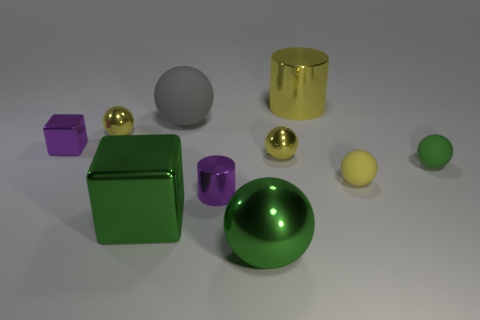Subtract all yellow balls. How many were subtracted if there are1yellow balls left? 2 Subtract all blue blocks. How many yellow spheres are left? 3 Subtract 2 balls. How many balls are left? 4 Subtract all green spheres. How many spheres are left? 4 Subtract all big balls. How many balls are left? 4 Subtract all cyan balls. Subtract all gray cylinders. How many balls are left? 6 Subtract all cylinders. How many objects are left? 8 Add 2 yellow shiny balls. How many yellow shiny balls are left? 4 Add 4 tiny blocks. How many tiny blocks exist? 5 Subtract 0 red blocks. How many objects are left? 10 